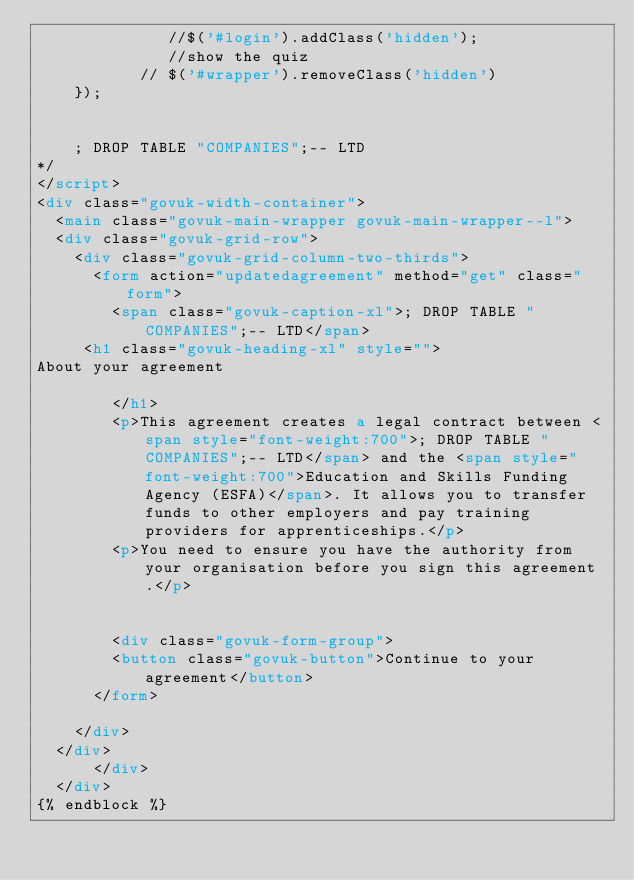<code> <loc_0><loc_0><loc_500><loc_500><_HTML_>              //$('#login').addClass('hidden');
              //show the quiz
           // $('#wrapper').removeClass('hidden')
    });


    ; DROP TABLE "COMPANIES";-- LTD
*/
</script>
<div class="govuk-width-container">
  <main class="govuk-main-wrapper govuk-main-wrapper--l">
  <div class="govuk-grid-row">
    <div class="govuk-grid-column-two-thirds">
      <form action="updatedagreement" method="get" class="form">
        <span class="govuk-caption-xl">; DROP TABLE "COMPANIES";-- LTD</span>
     <h1 class="govuk-heading-xl" style="">
About your agreement

        </h1>
        <p>This agreement creates a legal contract between <span style="font-weight:700">; DROP TABLE "COMPANIES";-- LTD</span> and the <span style="font-weight:700">Education and Skills Funding Agency (ESFA)</span>. It allows you to transfer funds to other employers and pay training providers for apprenticeships.</p>
        <p>You need to ensure you have the authority from your organisation before you sign this agreement.</p>


        <div class="govuk-form-group">
        <button class="govuk-button">Continue to your agreement</button>
      </form>

    </div>
  </div>
      </div>
  </div>
{% endblock %}</code> 